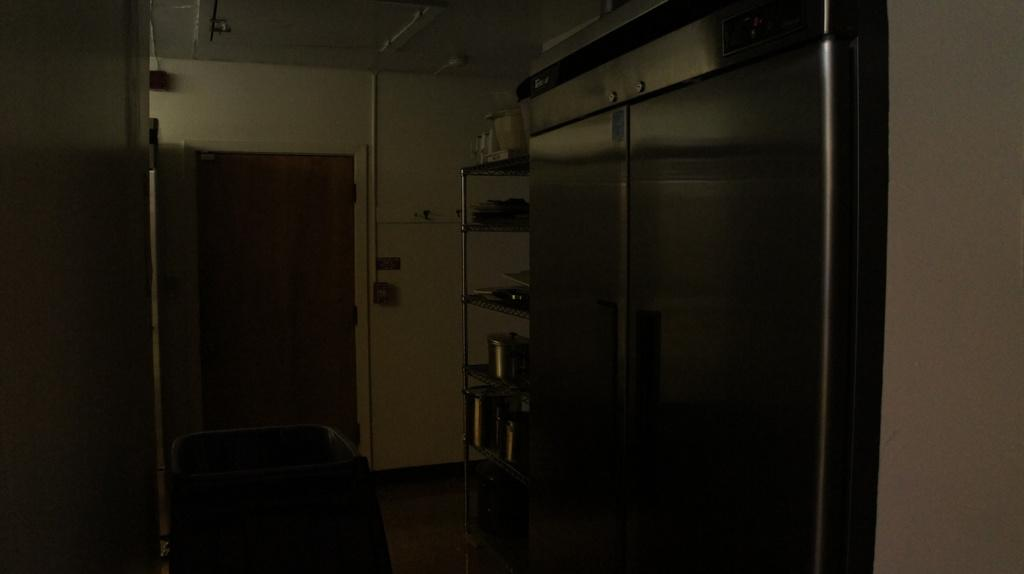What type of furniture is present in the image? There is a rack in the image, which resembles a refrigerator. What feature does the rack have? The rack has a door in the image. What can be seen on the rack? There are objects on the rack in the image. What is visible in the background of the image? There is a wall in the background of the image. Can you see any pies floating in the ocean in the image? There is no ocean or pie present in the image; it features a rack with a door and objects on it. Is there a bomb visible on the rack in the image? There is no bomb present on the rack in the image; it contains objects that are not specified. 